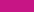<chart> <loc_0><loc_0><loc_500><loc_500><pie_chart><ecel><nl><fcel>100.0%<nl></chart> 